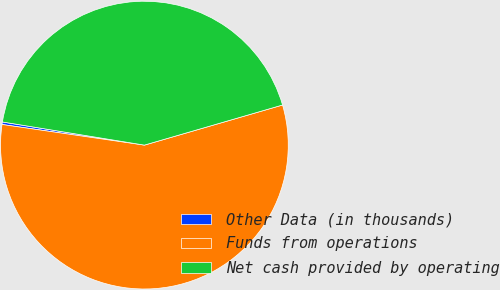<chart> <loc_0><loc_0><loc_500><loc_500><pie_chart><fcel>Other Data (in thousands)<fcel>Funds from operations<fcel>Net cash provided by operating<nl><fcel>0.28%<fcel>56.79%<fcel>42.93%<nl></chart> 